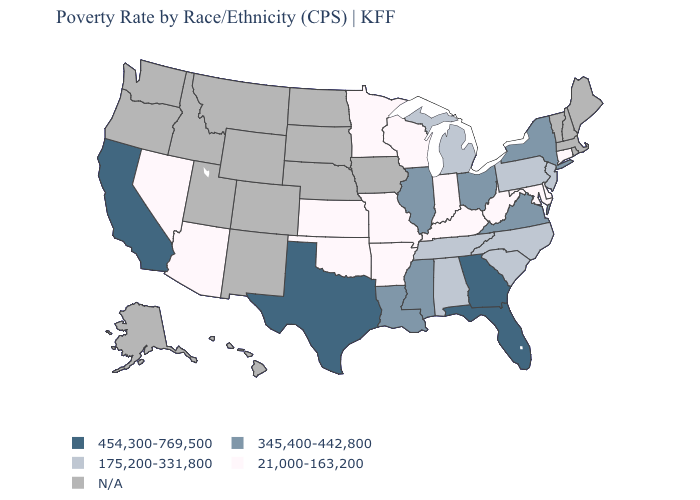What is the value of Nebraska?
Short answer required. N/A. What is the lowest value in the MidWest?
Give a very brief answer. 21,000-163,200. Name the states that have a value in the range 21,000-163,200?
Keep it brief. Arizona, Arkansas, Connecticut, Delaware, Indiana, Kansas, Kentucky, Maryland, Minnesota, Missouri, Nevada, Oklahoma, West Virginia, Wisconsin. Does the first symbol in the legend represent the smallest category?
Concise answer only. No. Which states have the highest value in the USA?
Be succinct. California, Florida, Georgia, Texas. What is the value of New Mexico?
Write a very short answer. N/A. Is the legend a continuous bar?
Quick response, please. No. What is the value of Pennsylvania?
Answer briefly. 175,200-331,800. Name the states that have a value in the range 21,000-163,200?
Short answer required. Arizona, Arkansas, Connecticut, Delaware, Indiana, Kansas, Kentucky, Maryland, Minnesota, Missouri, Nevada, Oklahoma, West Virginia, Wisconsin. Among the states that border Texas , does Louisiana have the highest value?
Keep it brief. Yes. How many symbols are there in the legend?
Give a very brief answer. 5. What is the value of Alabama?
Concise answer only. 175,200-331,800. Among the states that border Connecticut , which have the lowest value?
Keep it brief. New York. What is the value of Rhode Island?
Keep it brief. N/A. 